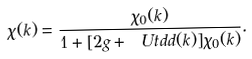<formula> <loc_0><loc_0><loc_500><loc_500>\chi ( k ) = \frac { \chi _ { 0 } ( k ) } { 1 + [ 2 g + \ U t d d ( k ) ] \chi _ { 0 } ( k ) } .</formula> 